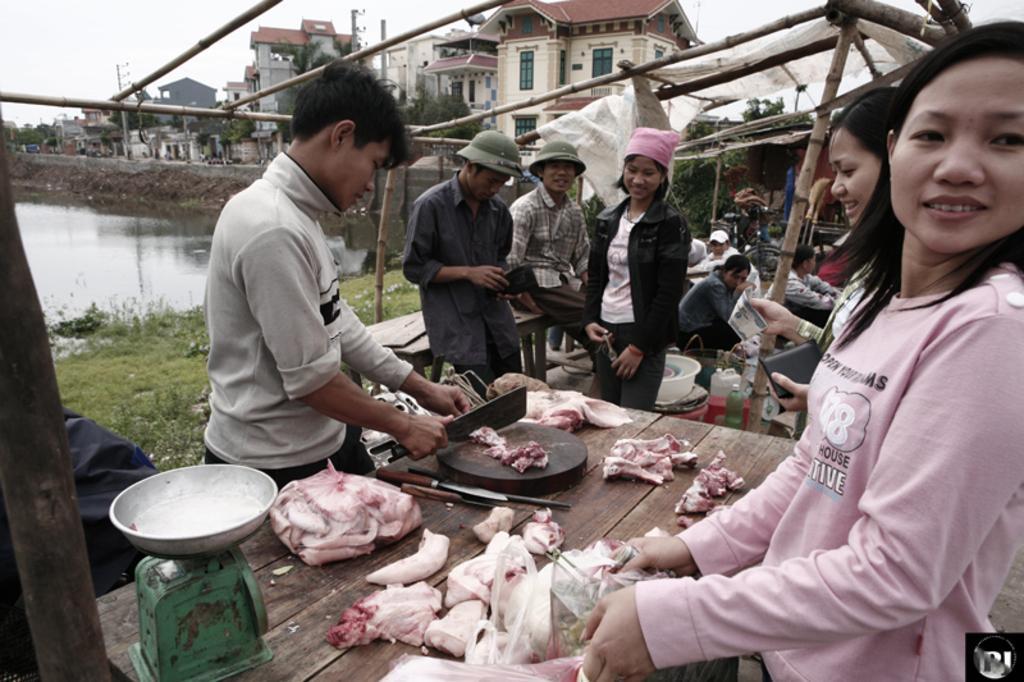Describe this image in one or two sentences. In this image there are people standing and a person cutting meat, in the background there are people sitting and there are houses, pond and the sky. 